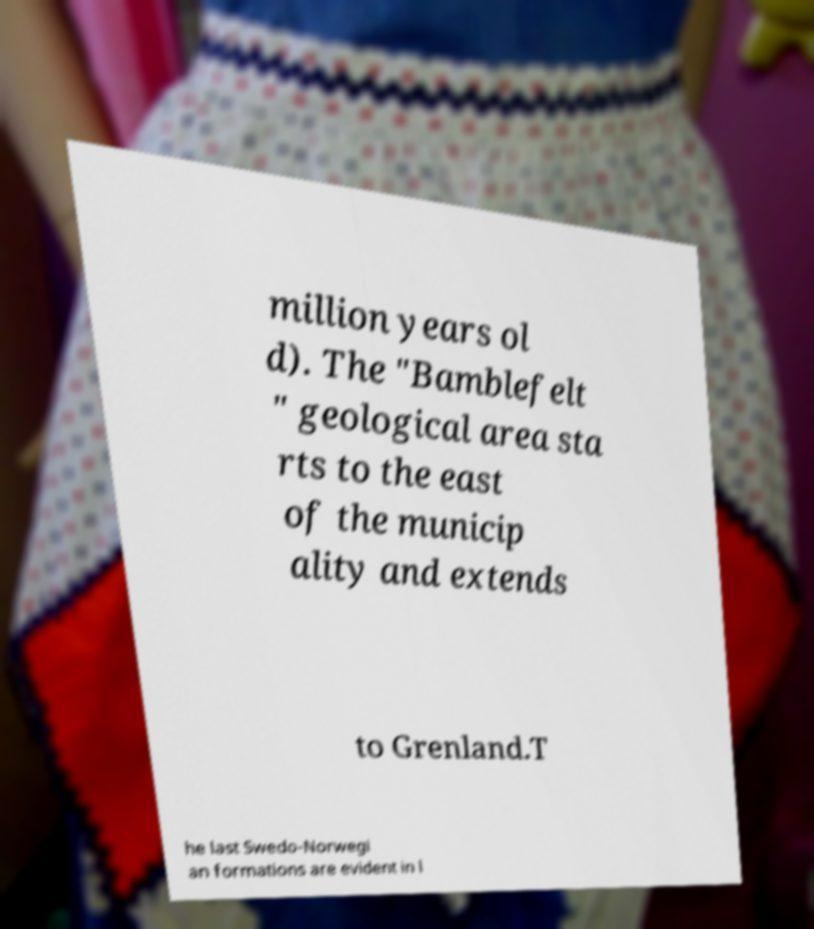Could you assist in decoding the text presented in this image and type it out clearly? million years ol d). The "Bamblefelt " geological area sta rts to the east of the municip ality and extends to Grenland.T he last Swedo-Norwegi an formations are evident in l 